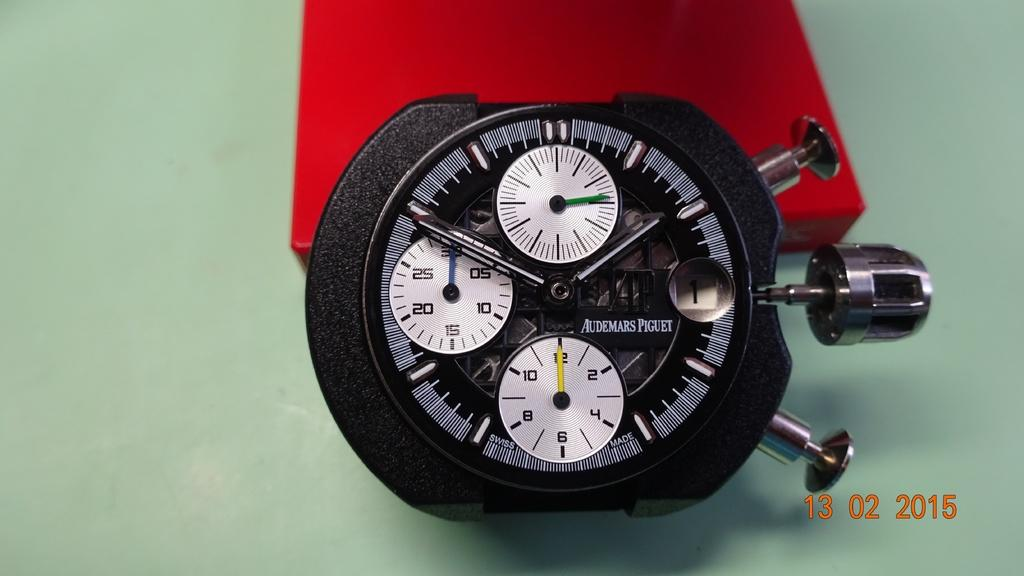<image>
Present a compact description of the photo's key features. A black stopwatch leaning on a red box has several faces and smaller clocks within it and writing that reads Audemars Piguet on it. 